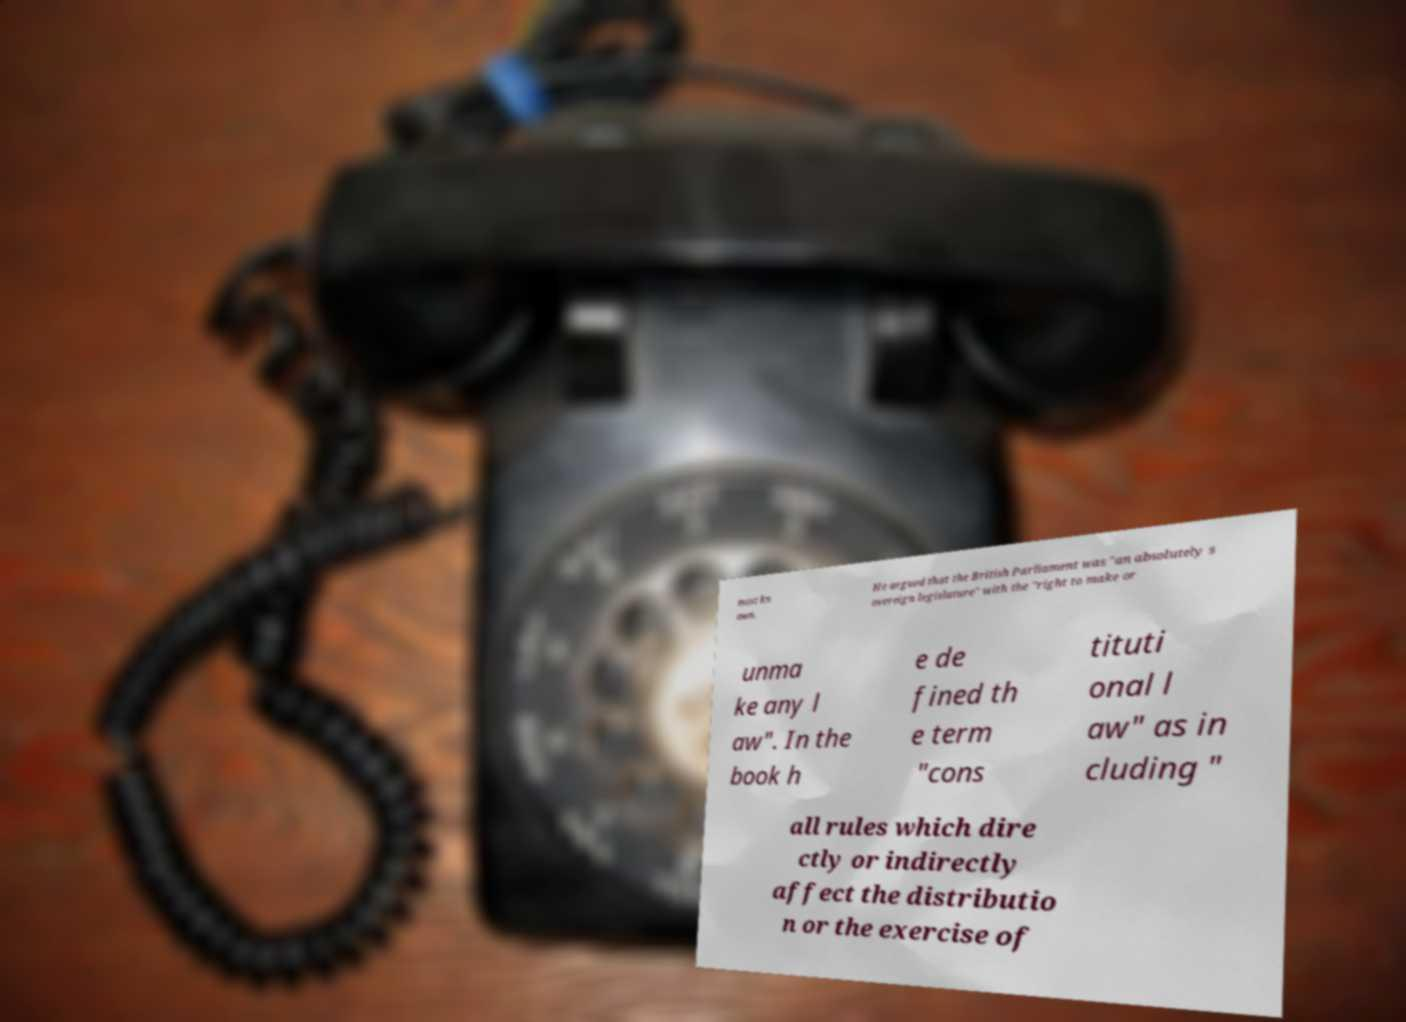Could you assist in decoding the text presented in this image and type it out clearly? most kn own. He argued that the British Parliament was "an absolutely s overeign legislature" with the "right to make or unma ke any l aw". In the book h e de fined th e term "cons tituti onal l aw" as in cluding " all rules which dire ctly or indirectly affect the distributio n or the exercise of 